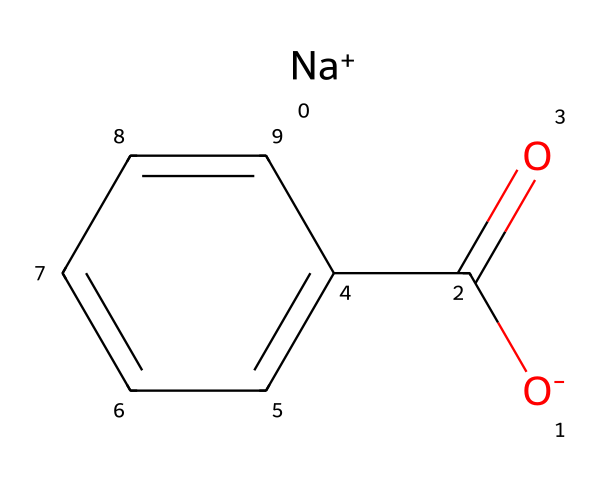What is the molecular formula of sodium benzoate? The molecular formula is derived from the elements present in the chemical structure. The structure indicates the presence of sodium (Na), carbon (C), hydrogen (H), and oxygen (O). Counting the relevant atoms gives C7H5O2Na.
Answer: C7H5O2Na How many carbon atoms are in sodium benzoate? The structure of sodium benzoate shows a total of seven carbon atoms connected in a specific arrangement. Counting the carbon atoms in the structure confirms this.
Answer: 7 Which functional group is present in sodium benzoate? The chemical structure clearly shows a carboxylate group (-COO-) as part of its composition, indicating the presence of a carboxylic acid derivative.
Answer: carboxylate What role does sodium benzoate play in energy drinks? Sodium benzoate acts as a preservative in energy drinks, helping to prevent spoilage by inhibiting the growth of bacteria and fungi.
Answer: preservative How does the structure of sodium benzoate relate to its function as a preservative? Sodium benzoate’s structure contains a hydrophobic benzene ring that allows it to integrate into the lipid membranes of microorganisms, while the carboxylate group helps in its antimicrobial properties. This combination makes it effective in preserving food and drinks.
Answer: effective antimicrobial properties 